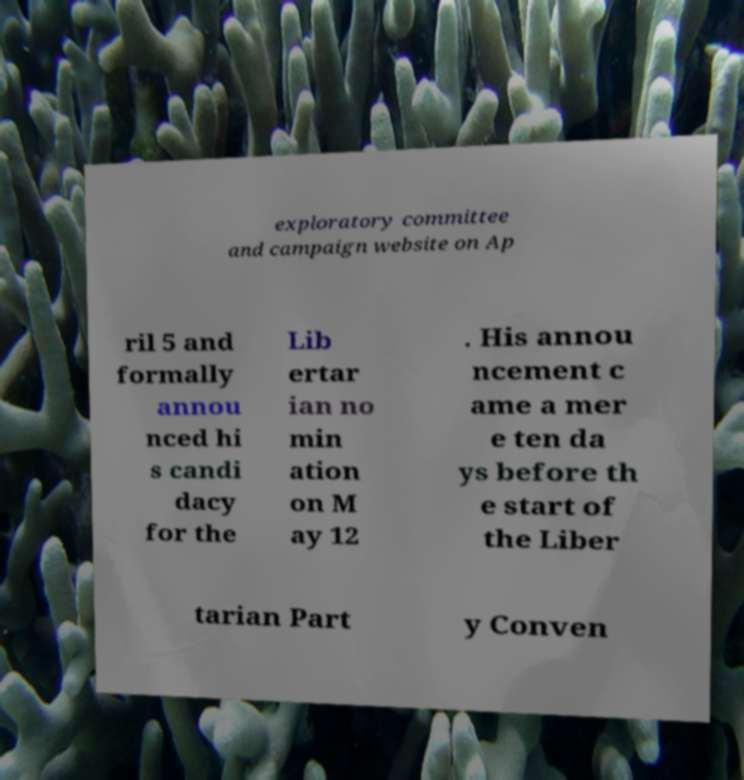Could you assist in decoding the text presented in this image and type it out clearly? exploratory committee and campaign website on Ap ril 5 and formally annou nced hi s candi dacy for the Lib ertar ian no min ation on M ay 12 . His annou ncement c ame a mer e ten da ys before th e start of the Liber tarian Part y Conven 